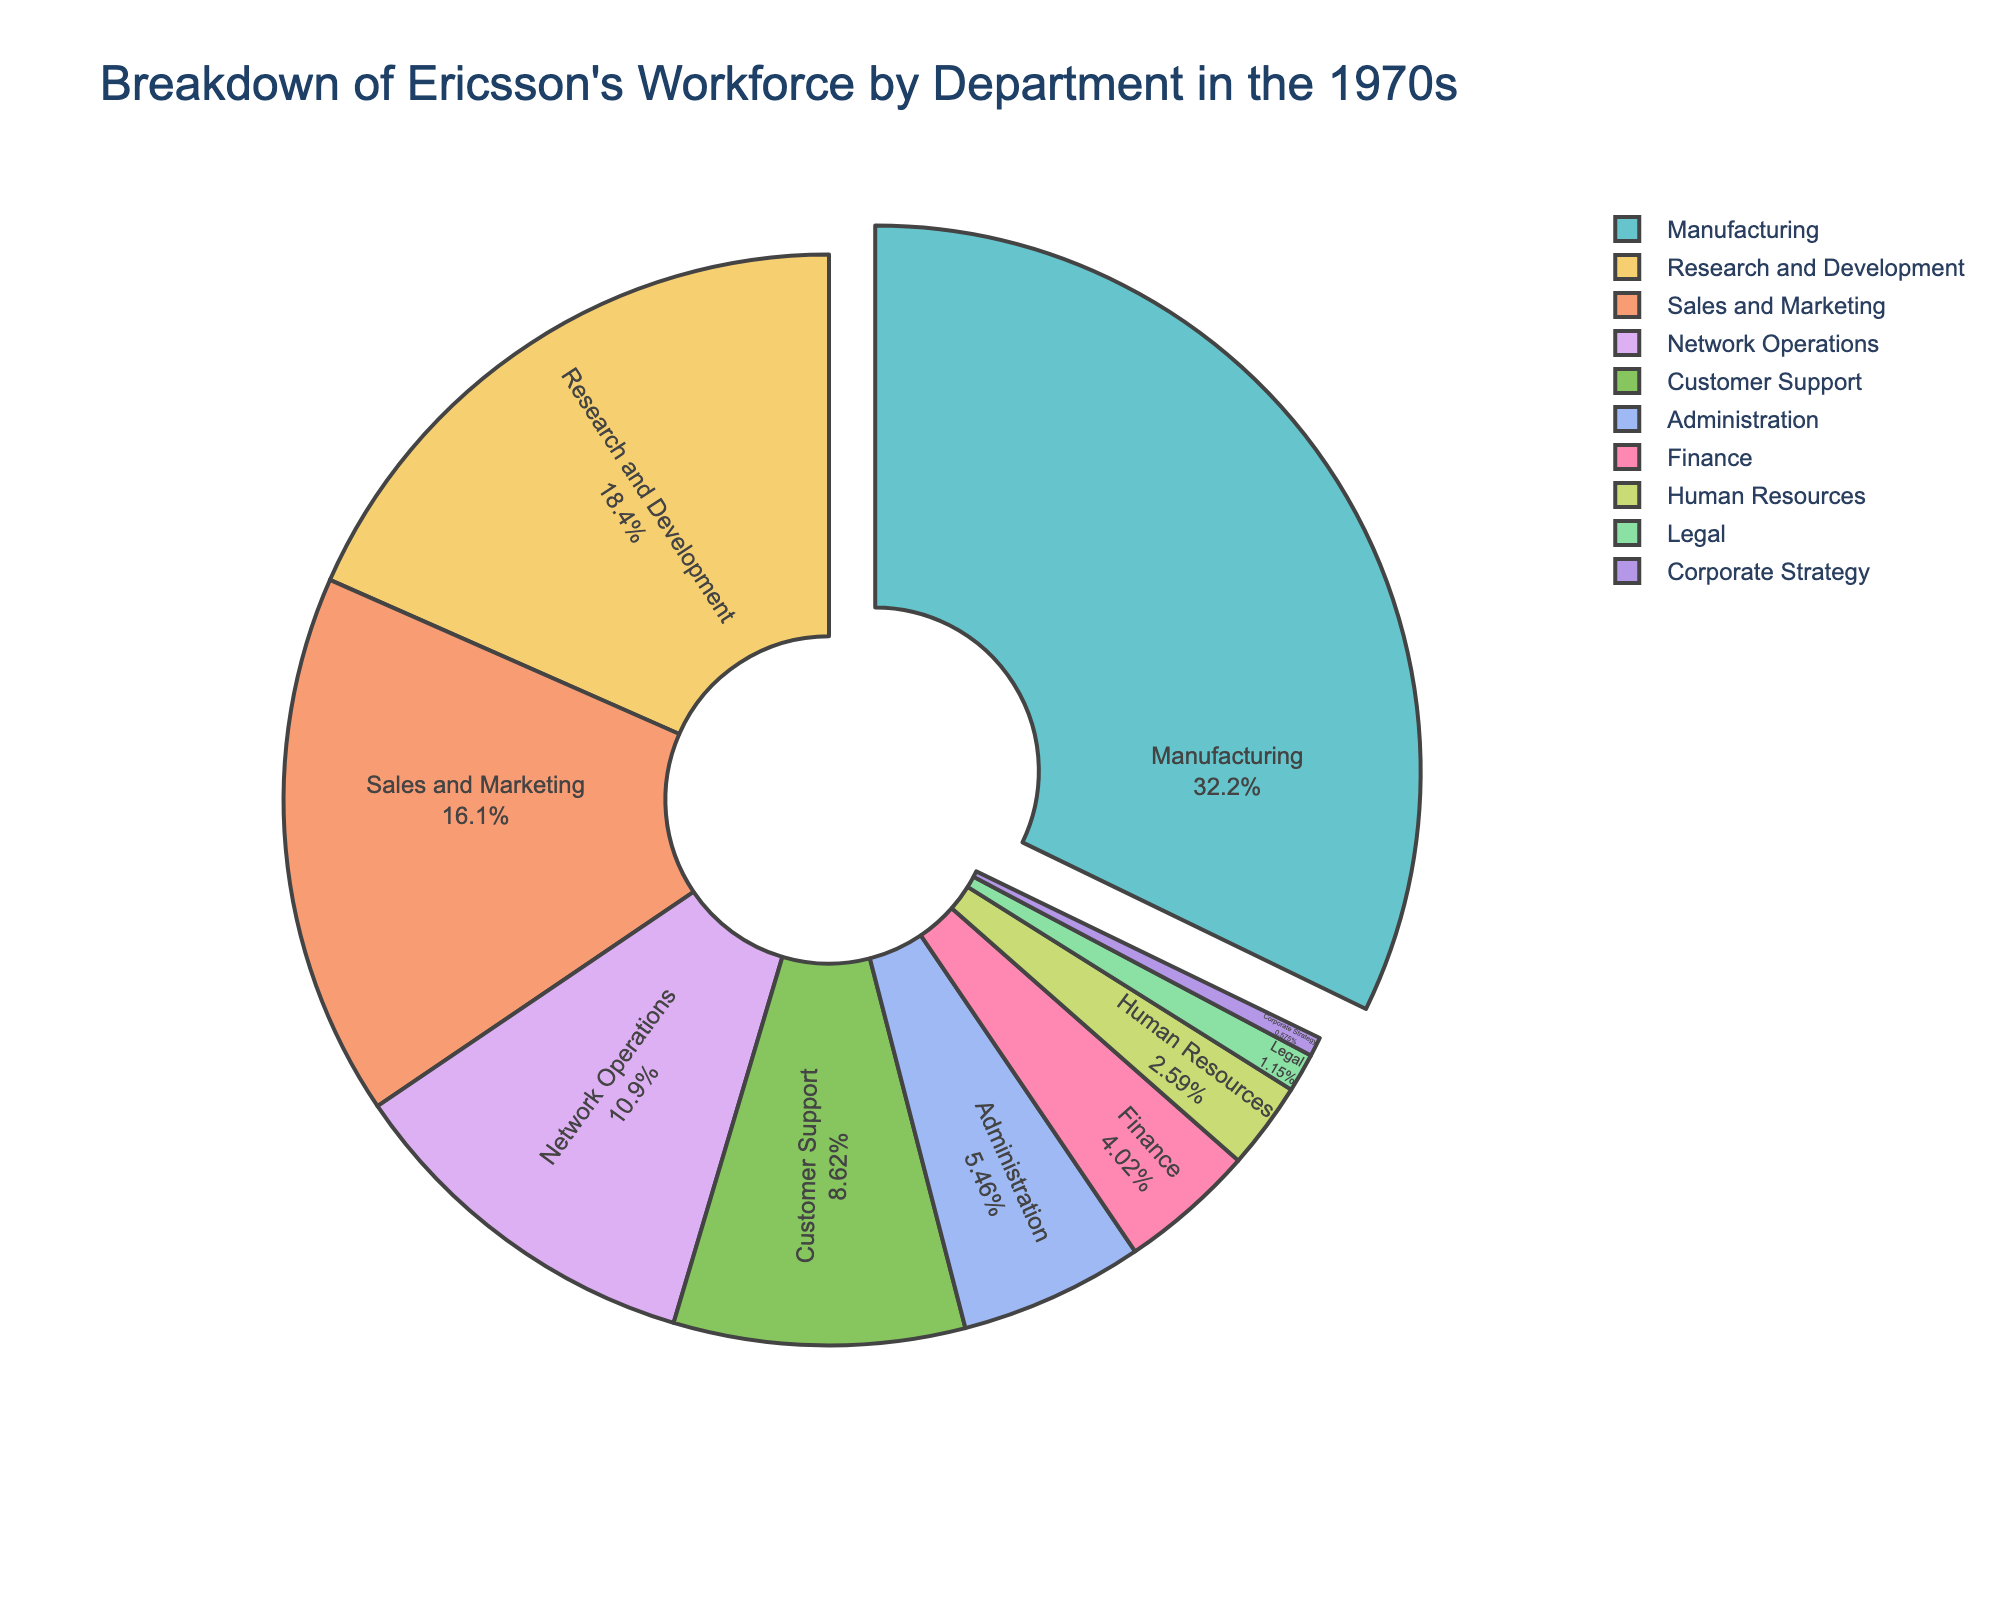What percentage of Ericsson's workforce was employed in the Manufacturing department in the 1970s? Refer to the labeled percentage inside the segment that represents the Manufacturing department on the pie chart.
Answer: 35% Which two departments together have the highest combined percentage of employees? Identify the two largest segments on the pie chart and add their percentages together. The two largest segments are Manufacturing and Research and Development.
Answer: Manufacturing and Research and Development How many more employees are there in Sales and Marketing compared to Legal? Find the employee figures for Sales and Marketing (2800) and Legal (200). Subtract the number of employees in Legal from those in Sales and Marketing (2800 - 200).
Answer: 2600 Which department has the smallest slice in the pie chart? Look for the smallest segment of the pie chart, which should be labeled accordingly. The smallest segment is for the Corporate Strategy department.
Answer: Corporate Strategy Are there more employees in Network Operations or Customer Support? Compare the sizes of the segments representing Network Operations and Customer Support. Network Operations has more employees (1900) than Customer Support (1500).
Answer: Network Operations What is the total number of employees represented in the pie chart? Add the number of employees from all the departments: 3200 (R&D) + 5600 (Manufacturing) + 2800 (Sales and Marketing) + 1900 (Network Operations) + 1500 (Customer Support) + 950 (Administration) + 700 (Finance) + 450 (Human Resources) + 200 (Legal) + 100 (Corporate Strategy).
Answer: 17400 How does the employee count in Administration compare to that in Finance? Find the employee figures for Administration (950) and Finance (700). Administration has more employees than Finance.
Answer: Administration has more employees Which three departments have the largest proportion of employees? Identify the three largest segments on the pie chart. These are Manufacturing, Research and Development, and Sales and Marketing.
Answer: Manufacturing, Research and Development, Sales and Marketing How many departments have fewer than 1000 employees? Count the segments with fewer than 1000 employees each. These departments are Finance (700), Human Resources (450), Legal (200), and Corporate Strategy (100).
Answer: 4 